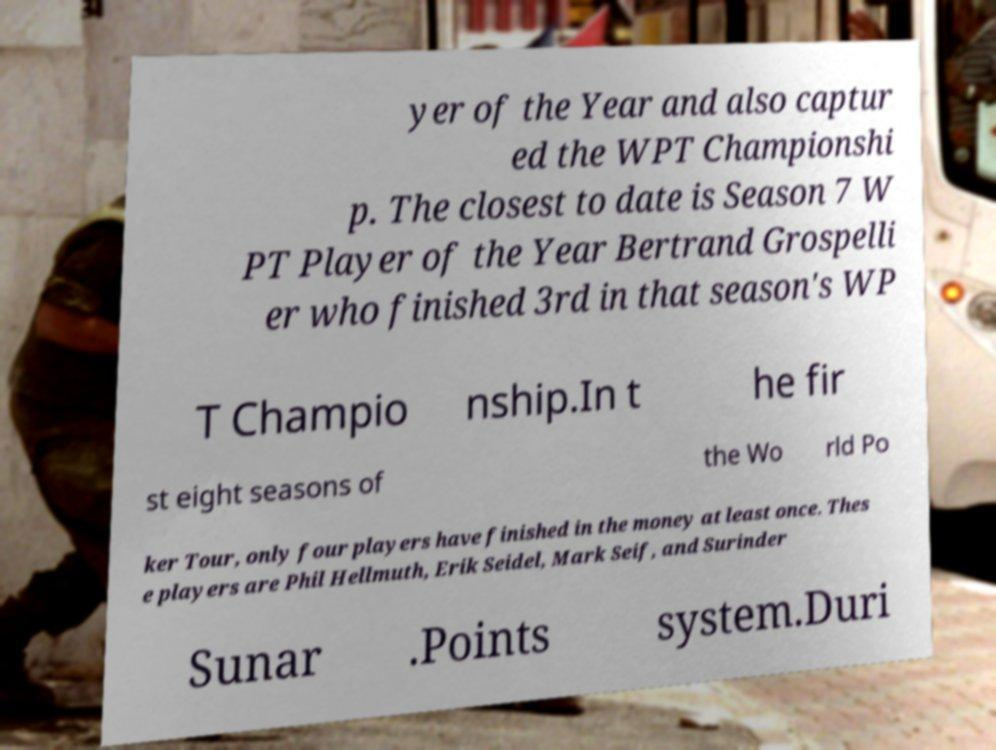I need the written content from this picture converted into text. Can you do that? yer of the Year and also captur ed the WPT Championshi p. The closest to date is Season 7 W PT Player of the Year Bertrand Grospelli er who finished 3rd in that season's WP T Champio nship.In t he fir st eight seasons of the Wo rld Po ker Tour, only four players have finished in the money at least once. Thes e players are Phil Hellmuth, Erik Seidel, Mark Seif, and Surinder Sunar .Points system.Duri 